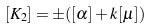<formula> <loc_0><loc_0><loc_500><loc_500>[ K _ { 2 } ] = \pm ( [ \alpha ] + k [ \mu ] )</formula> 